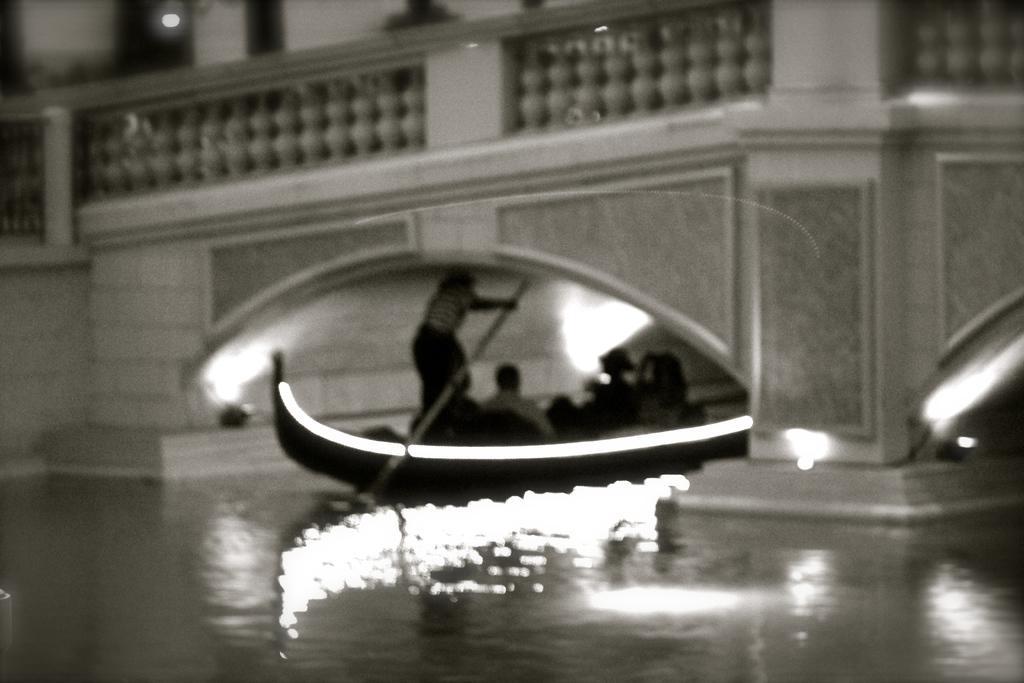In one or two sentences, can you explain what this image depicts? In this image I can see the group of people sitting on the boat. I can see the boat on the water. In the background I can see the building with lights and the railing. And this is a black and white image. 